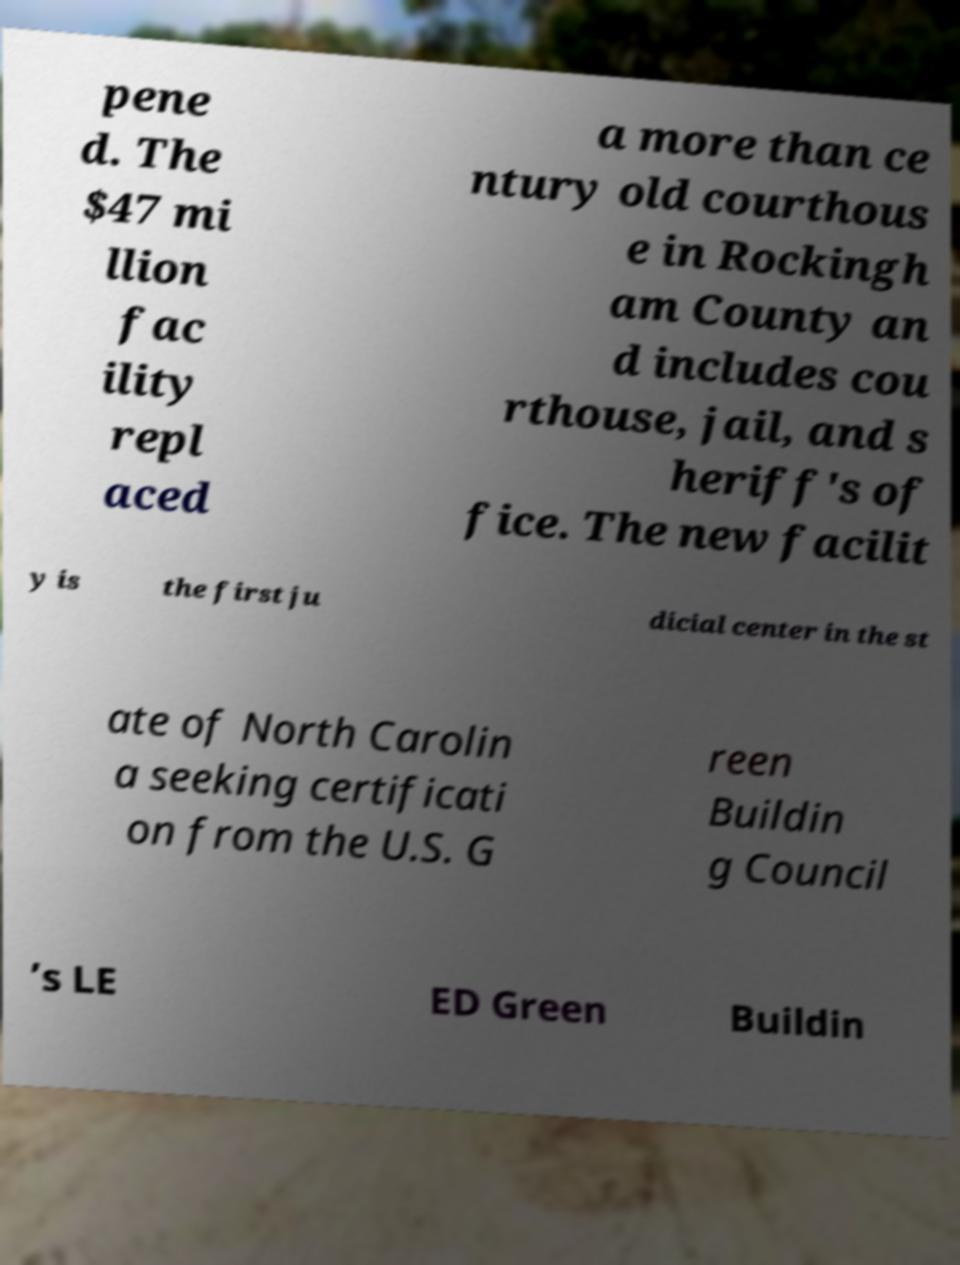Could you extract and type out the text from this image? pene d. The $47 mi llion fac ility repl aced a more than ce ntury old courthous e in Rockingh am County an d includes cou rthouse, jail, and s heriff's of fice. The new facilit y is the first ju dicial center in the st ate of North Carolin a seeking certificati on from the U.S. G reen Buildin g Council ’s LE ED Green Buildin 